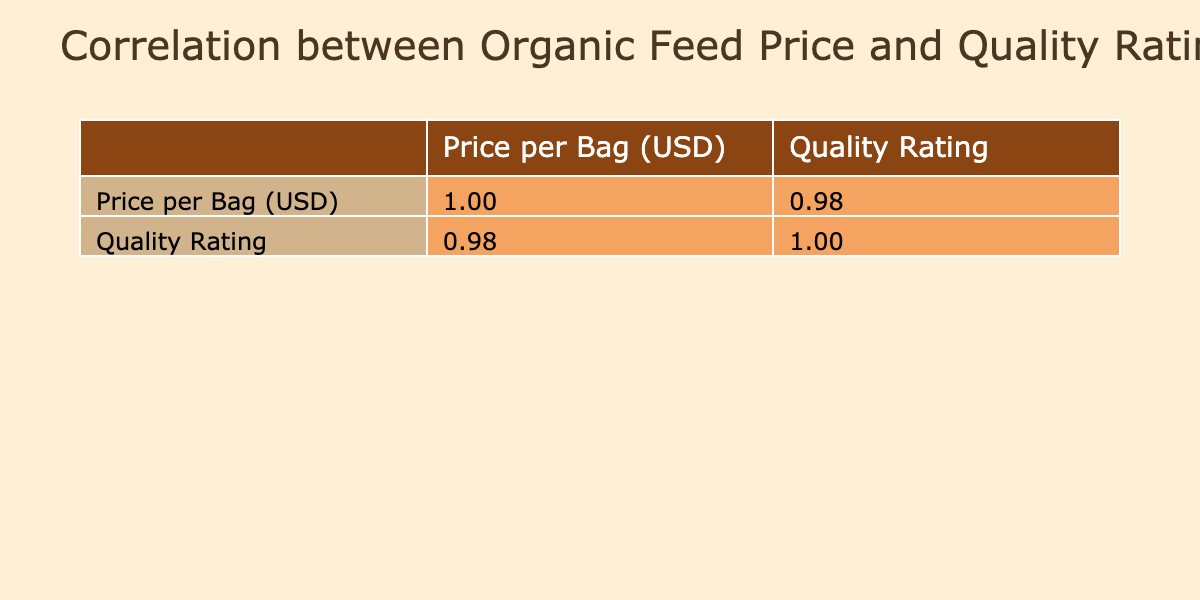What is the correlation coefficient between the price per bag and the quality rating? The table shows two values for the correlation: the first row indicates the correlation of price with itself (which is always 1.00), and the second row indicates the correlation between price and quality rating at 0.88.
Answer: 0.88 Which organic feed brand has the highest quality rating? The premium grains brand shows the highest quality rating of 9.5 according to the table provided.
Answer: PremiumGrains Is there any organic feed brand with a quality rating below 7? The table provides details that indicate FarmFresh (6.5) and WholesomeFeeder (6.8) have quality ratings below 7. Therefore, the answer is yes.
Answer: Yes What is the average quality rating for organic feed brands that cost less than 40 USD per bag? The brands Nature'sBest (7.0), FarmFresh (6.5), and WholesomeFeeder (6.8) have prices below 40 USD, yielding an average rating of (7.0 + 6.5 + 6.8) / 3 = 6.77.
Answer: 6.77 How much does the quality rating increase for every 10 USD increase in the price per bag based on the correlation? The correlation coefficient indicates that for every one-unit increase in price, the quality rating increases by 0.88. Therefore, for every 10 USD increase, the rating would increase by 0.88 * 10 = 8.8 points.
Answer: 8.8 points What is the lowest priced organic feed brand that has a quality rating above 8? Checking the table, OrganicHoof (48.00 USD) is the lowest price among the brands with a quality rating above 8 (8.8). Thus, the answer is OrganicHoof.
Answer: OrganicHoof Can you identify any brands where the price per bag is 45 USD or higher, while also checking if their quality ratings are above 8? Examining the brands, GreenPastures (9.0), OrganicHoof (8.8), and PremiumGrains (9.5) have prices at or above 45 USD and quality ratings above 8.
Answer: Yes What is the difference between the highest and lowest quality ratings among the organic feed brands? The highest quality rating is 9.5 (PremiumGrains) and the lowest is 6.5 (FarmFresh). Hence, the difference is 9.5 - 6.5 = 3.0.
Answer: 3.0 